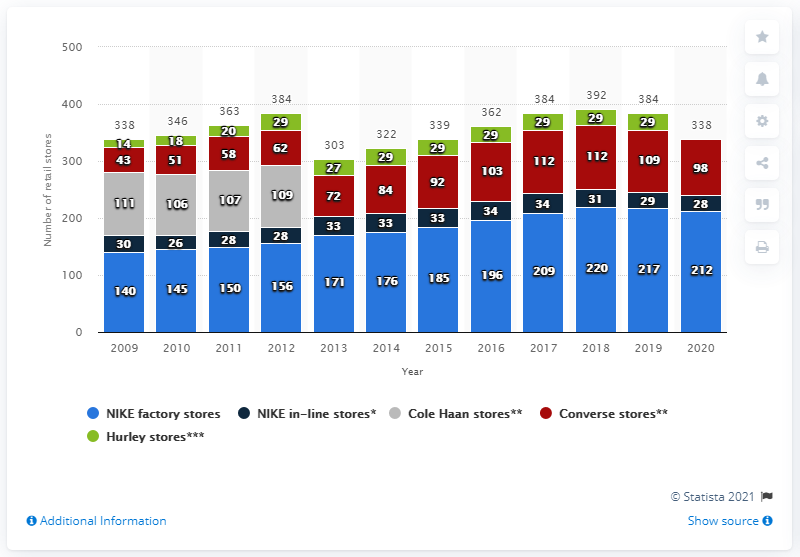Highlight a few significant elements in this photo. In 2020, Nike operated 98 Converse stores in the United States. 